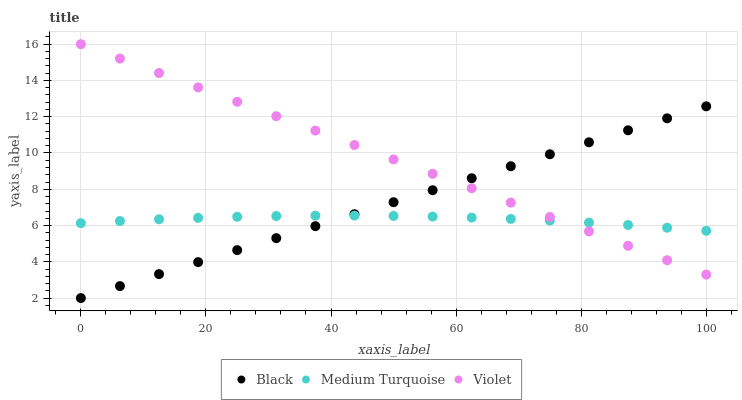Does Medium Turquoise have the minimum area under the curve?
Answer yes or no. Yes. Does Violet have the maximum area under the curve?
Answer yes or no. Yes. Does Violet have the minimum area under the curve?
Answer yes or no. No. Does Medium Turquoise have the maximum area under the curve?
Answer yes or no. No. Is Black the smoothest?
Answer yes or no. Yes. Is Medium Turquoise the roughest?
Answer yes or no. Yes. Is Violet the smoothest?
Answer yes or no. No. Is Violet the roughest?
Answer yes or no. No. Does Black have the lowest value?
Answer yes or no. Yes. Does Violet have the lowest value?
Answer yes or no. No. Does Violet have the highest value?
Answer yes or no. Yes. Does Medium Turquoise have the highest value?
Answer yes or no. No. Does Black intersect Medium Turquoise?
Answer yes or no. Yes. Is Black less than Medium Turquoise?
Answer yes or no. No. Is Black greater than Medium Turquoise?
Answer yes or no. No. 